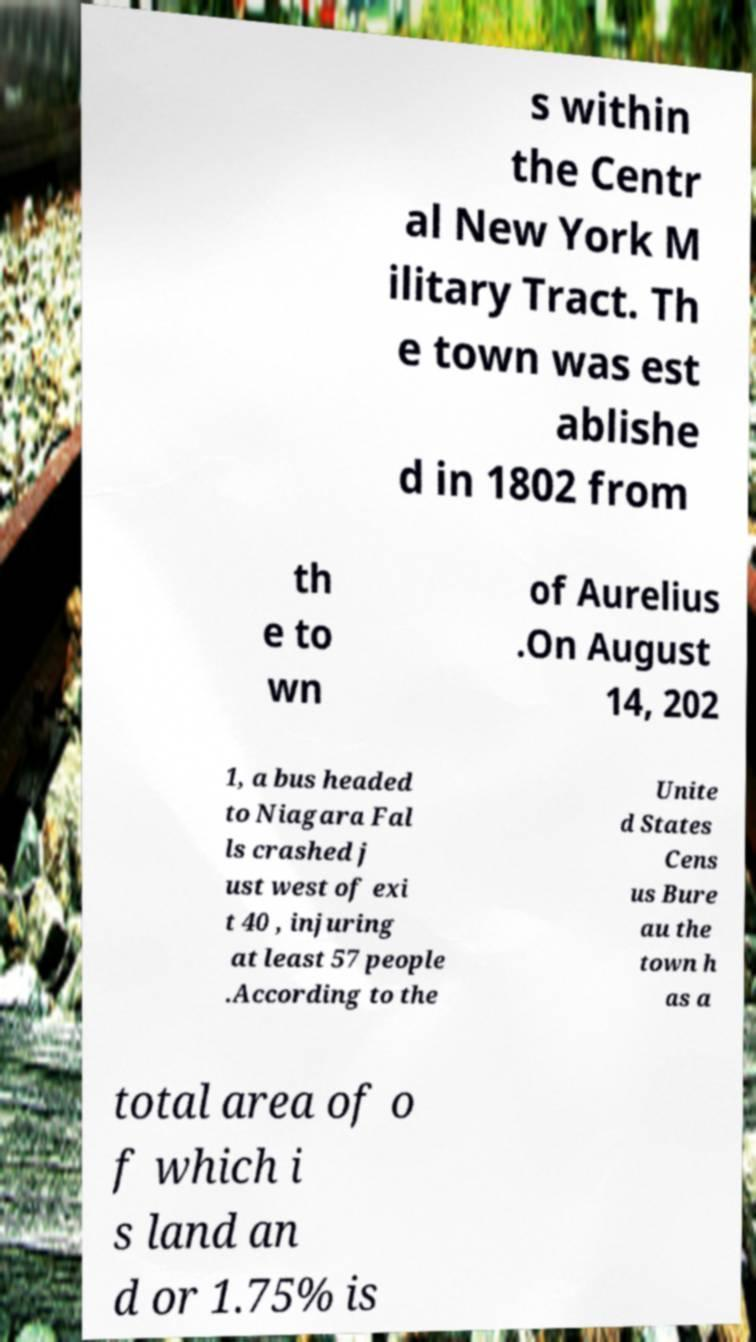What messages or text are displayed in this image? I need them in a readable, typed format. s within the Centr al New York M ilitary Tract. Th e town was est ablishe d in 1802 from th e to wn of Aurelius .On August 14, 202 1, a bus headed to Niagara Fal ls crashed j ust west of exi t 40 , injuring at least 57 people .According to the Unite d States Cens us Bure au the town h as a total area of o f which i s land an d or 1.75% is 